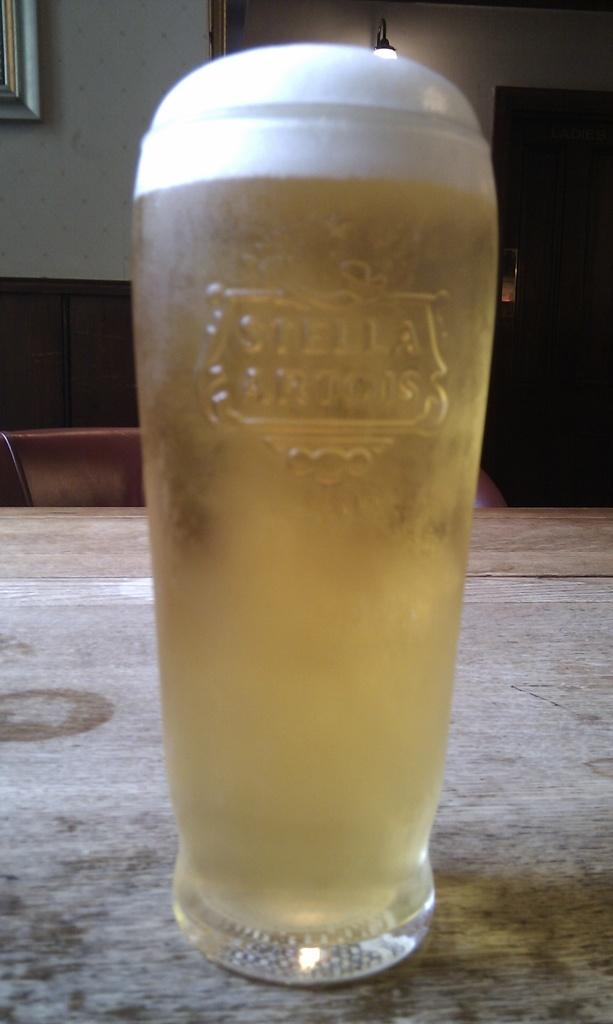What kind of beer is this, on the glass?
Make the answer very short. Stella artois. 